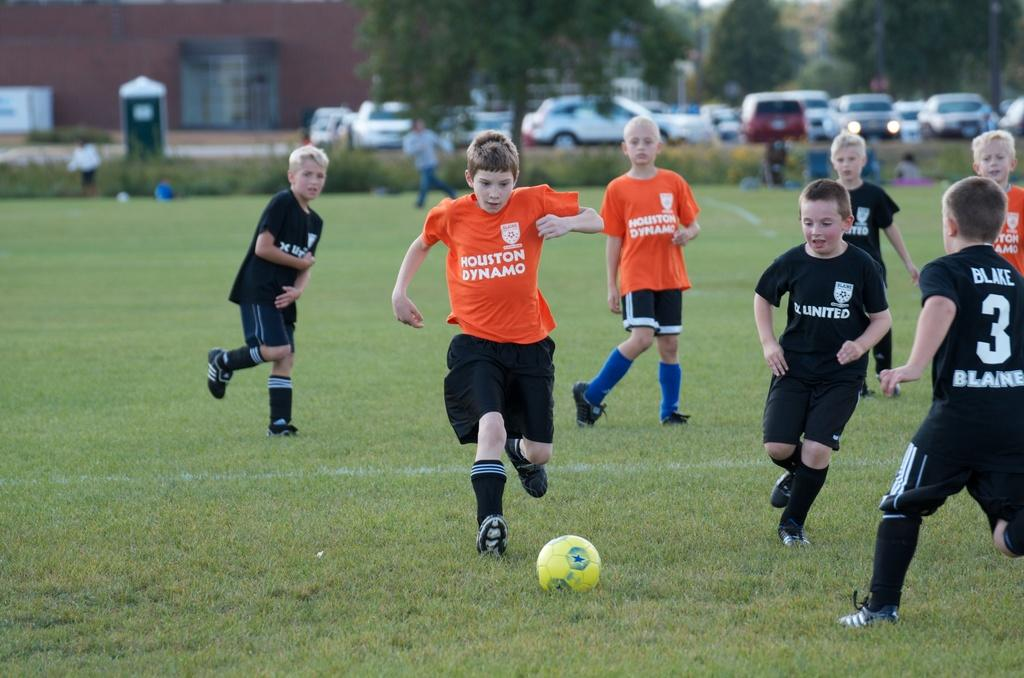What activity are the people in the image engaged in? The people in the image are playing football. Where is the football game taking place? The football game is taking place on a ground. What else can be seen in the image besides the football game? There are cars parked on the road and trees visible in the image. What is located behind the road in the image? There are buildings behind the road in the image. What type of fork can be seen in the image? There is no fork present in the image. What material is the linen made of in the image? There is no linen present in the image. 